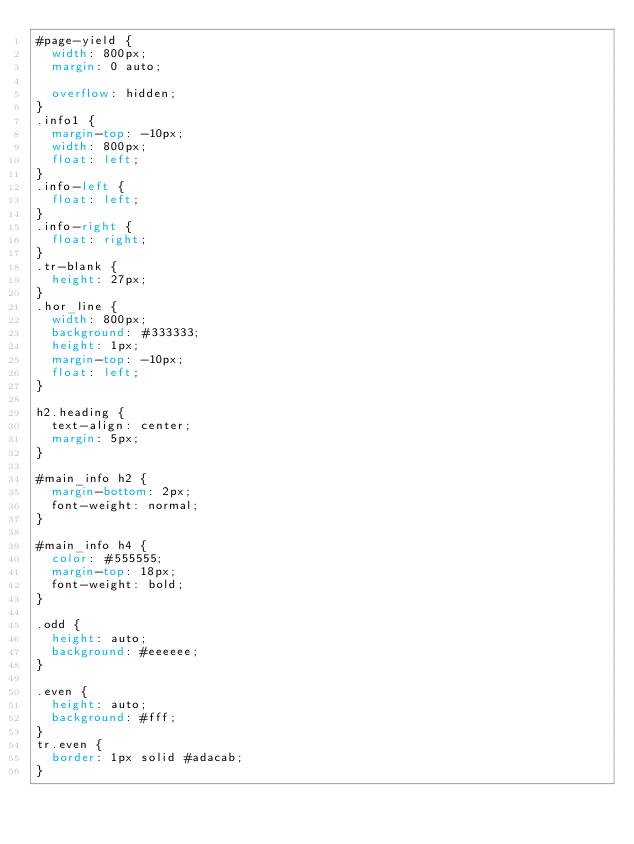<code> <loc_0><loc_0><loc_500><loc_500><_CSS_>#page-yield {
  width: 800px;
  margin: 0 auto;

  overflow: hidden;
}
.info1 {
  margin-top: -10px;
  width: 800px;
  float: left;
}
.info-left {
  float: left;
}
.info-right {
  float: right;
}
.tr-blank {
  height: 27px;
}
.hor_line {
  width: 800px;
  background: #333333;
  height: 1px;
  margin-top: -10px;
  float: left;
}

h2.heading {
  text-align: center;
  margin: 5px;
}

#main_info h2 {
  margin-bottom: 2px;
  font-weight: normal;
}

#main_info h4 {
  color: #555555;
  margin-top: 18px;
  font-weight: bold;
}

.odd {
  height: auto;
  background: #eeeeee;
}

.even {
  height: auto;
  background: #fff;
}
tr.even {
  border: 1px solid #adacab;
}
</code> 